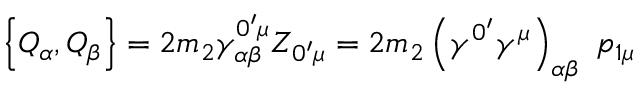<formula> <loc_0><loc_0><loc_500><loc_500>\left \{ Q _ { \alpha } , Q _ { \beta } \right \} = 2 m _ { 2 } \gamma _ { \alpha \beta } ^ { 0 ^ { \prime } \mu } Z _ { 0 ^ { \prime } \mu } = 2 m _ { 2 } \left ( \gamma ^ { 0 ^ { \prime } } \gamma ^ { \mu } \right ) _ { \alpha \beta } \, p _ { 1 \mu }</formula> 